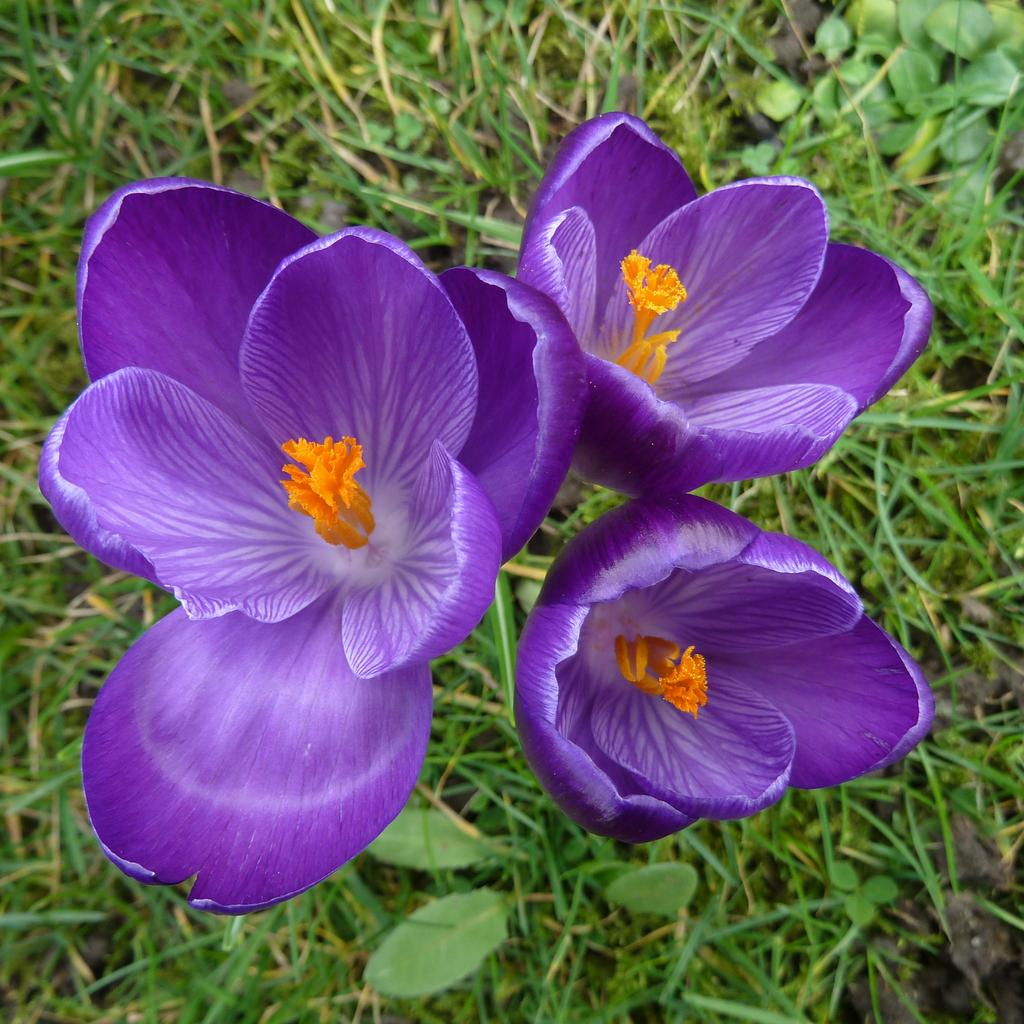What colors are the flowers in the image? The flowers in the image are in orange and purple colors. What can be seen in the background of the image? There are plants and grass in the background of the image. What color is the grass in the image? The grass in the image is in green color. How many tickets are visible in the image? There are no tickets present in the image. What type of stitch is used to create the flowers in the image? The flowers in the image are not handmade, so there is no stitching involved. 